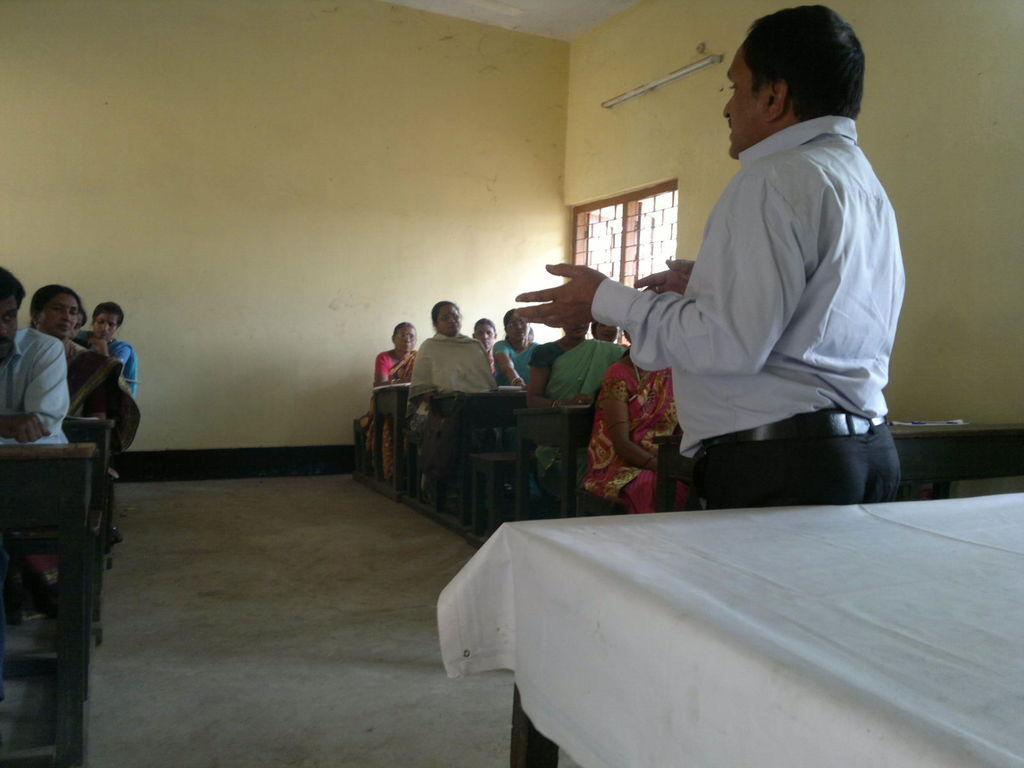Can you describe this image briefly? The picture is clicked inside a class room where many people are sitting on tables and a guy who is standing is explaining them, there is a white table to the right side of the image. In the background there is a window. 